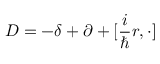Convert formula to latex. <formula><loc_0><loc_0><loc_500><loc_500>D = - \delta + \partial + [ \frac { i } { } r , \cdot ]</formula> 